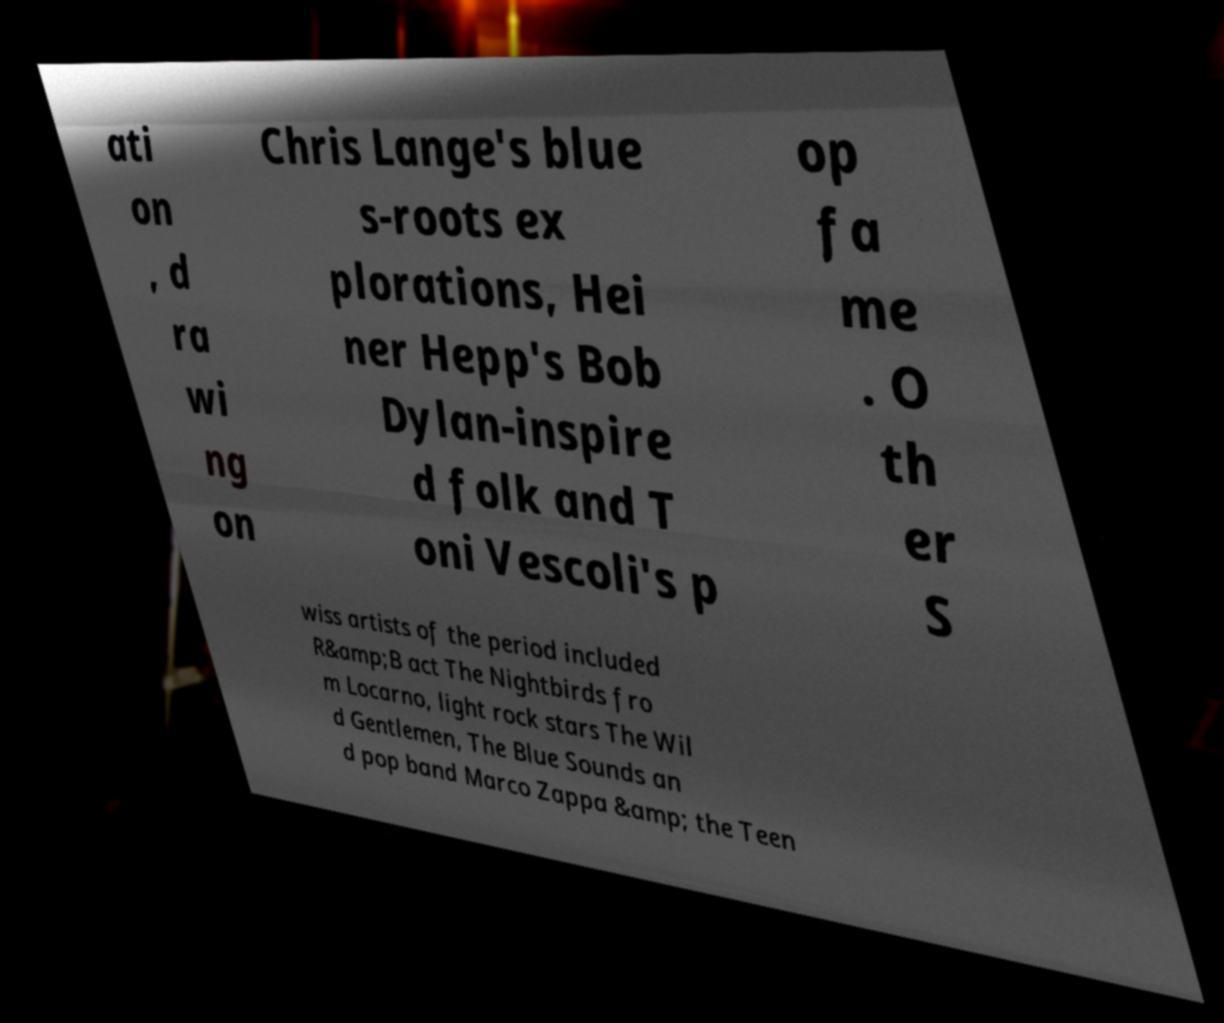Can you accurately transcribe the text from the provided image for me? ati on , d ra wi ng on Chris Lange's blue s-roots ex plorations, Hei ner Hepp's Bob Dylan-inspire d folk and T oni Vescoli's p op fa me . O th er S wiss artists of the period included R&amp;B act The Nightbirds fro m Locarno, light rock stars The Wil d Gentlemen, The Blue Sounds an d pop band Marco Zappa &amp; the Teen 